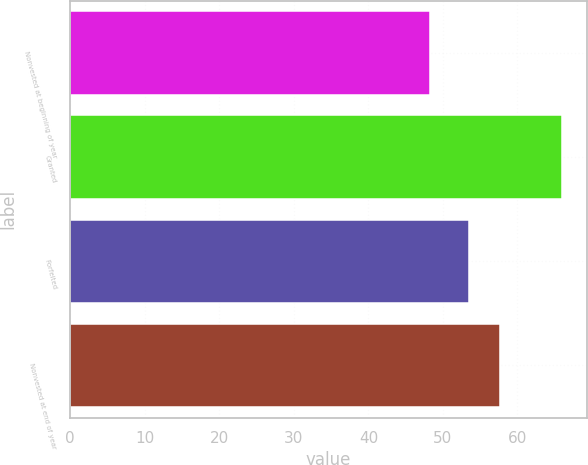Convert chart to OTSL. <chart><loc_0><loc_0><loc_500><loc_500><bar_chart><fcel>Nonvested at beginning of year<fcel>Granted<fcel>Forfeited<fcel>Nonvested at end of year<nl><fcel>48.24<fcel>65.98<fcel>53.52<fcel>57.66<nl></chart> 